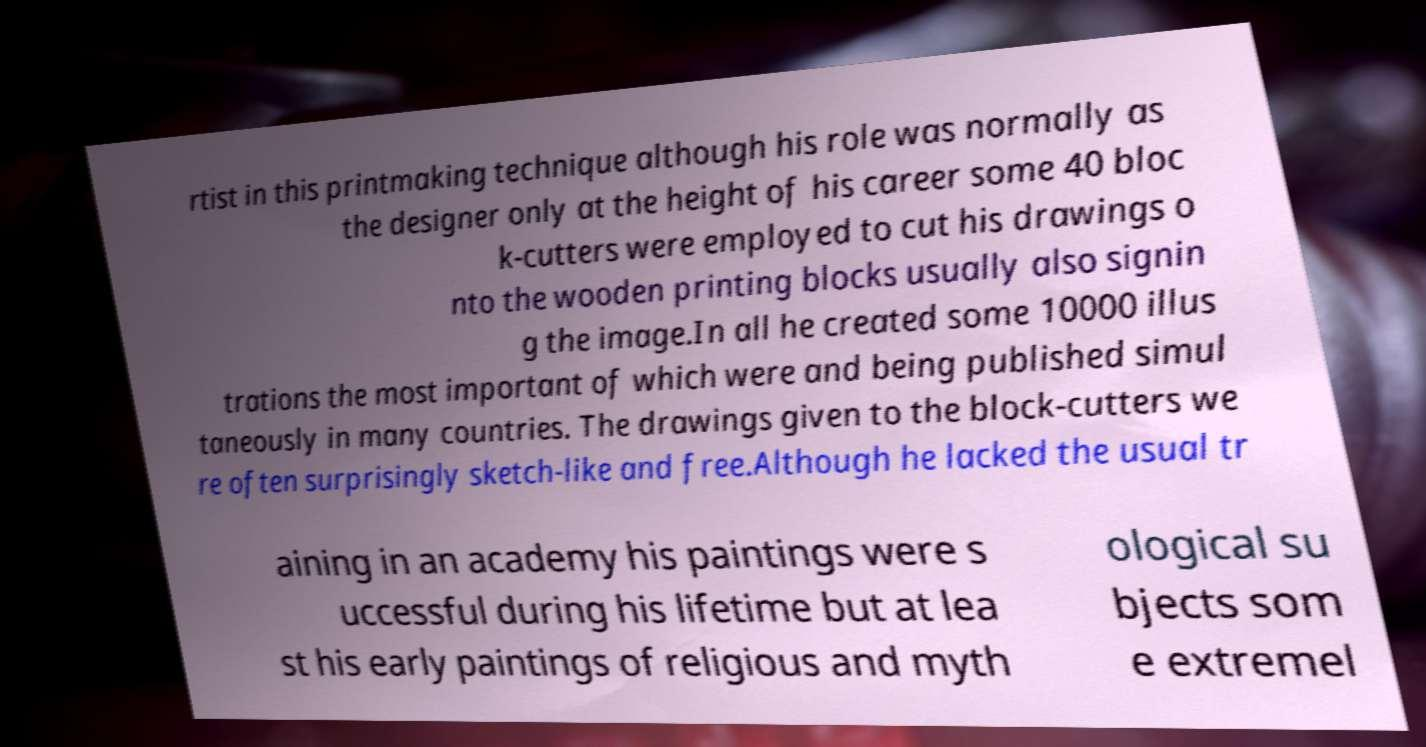Please read and relay the text visible in this image. What does it say? rtist in this printmaking technique although his role was normally as the designer only at the height of his career some 40 bloc k-cutters were employed to cut his drawings o nto the wooden printing blocks usually also signin g the image.In all he created some 10000 illus trations the most important of which were and being published simul taneously in many countries. The drawings given to the block-cutters we re often surprisingly sketch-like and free.Although he lacked the usual tr aining in an academy his paintings were s uccessful during his lifetime but at lea st his early paintings of religious and myth ological su bjects som e extremel 